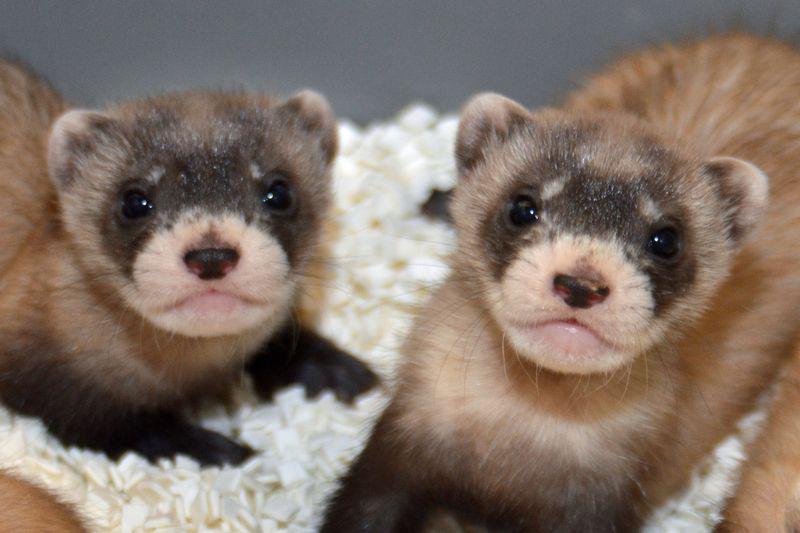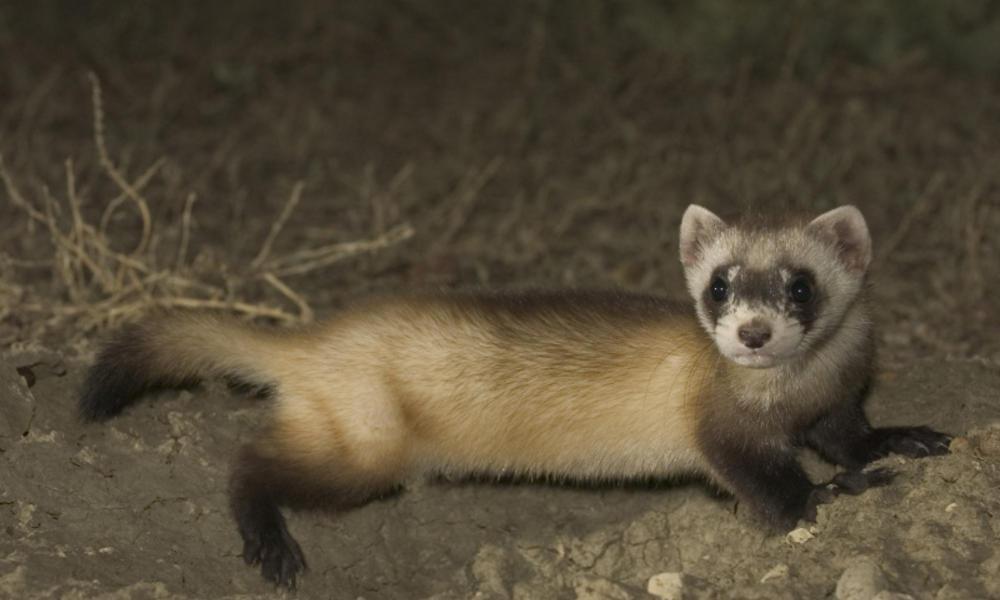The first image is the image on the left, the second image is the image on the right. Evaluate the accuracy of this statement regarding the images: "there are five animals in the image on the left". Is it true? Answer yes or no. No. The first image is the image on the left, the second image is the image on the right. Given the left and right images, does the statement "An image contains a row of five ferrets." hold true? Answer yes or no. No. 